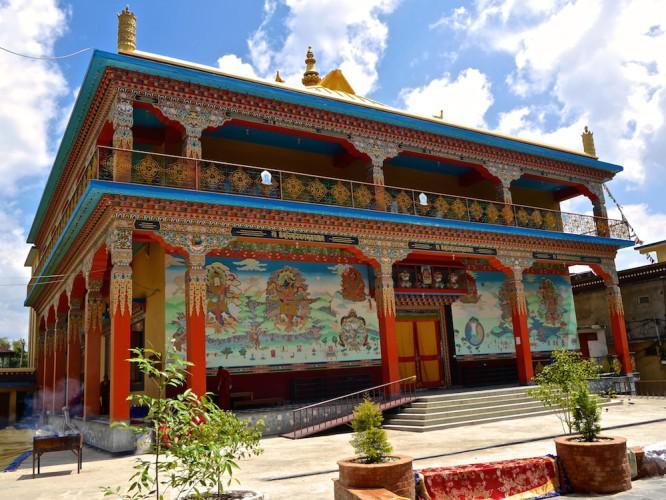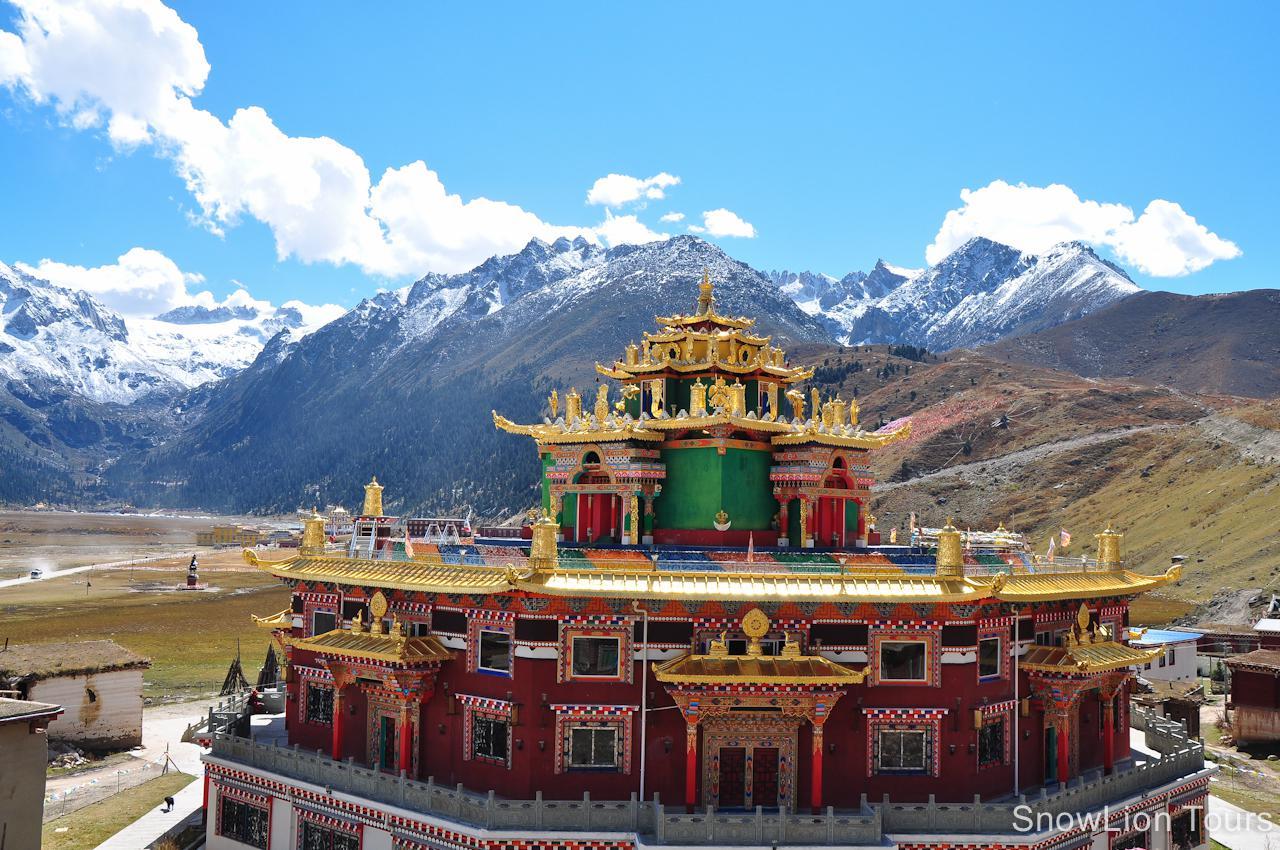The first image is the image on the left, the second image is the image on the right. Evaluate the accuracy of this statement regarding the images: "In one image, the walls running up the mountain towards a monastery are built up the steep slopes in a stair-like design.". Is it true? Answer yes or no. No. The first image is the image on the left, the second image is the image on the right. For the images displayed, is the sentence "A jagged, staircase-like wall goes up a hillside with a monastery on top, in one image." factually correct? Answer yes or no. No. 